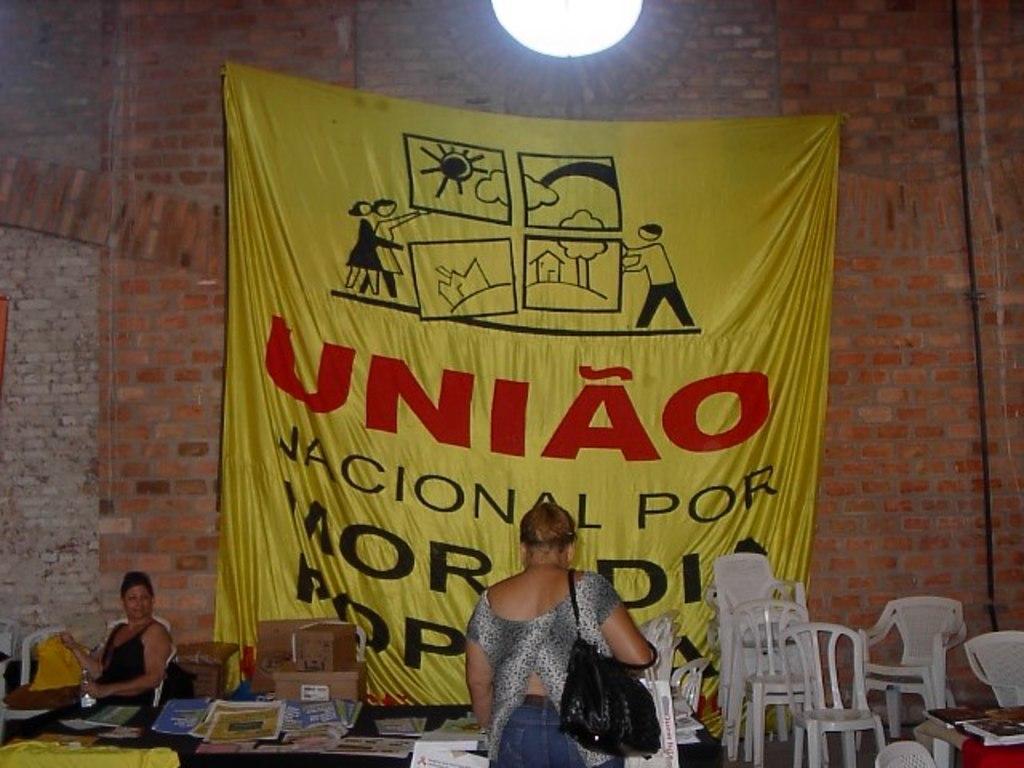Could you give a brief overview of what you see in this image? On wall there is a yellow banner. This person is sitting on a chair. Beside this person there are cardboard boxes. On this table there are papers. This woman is standing and holding a bag. We can see number of chairs. This wall is in red color and made with bricks. 